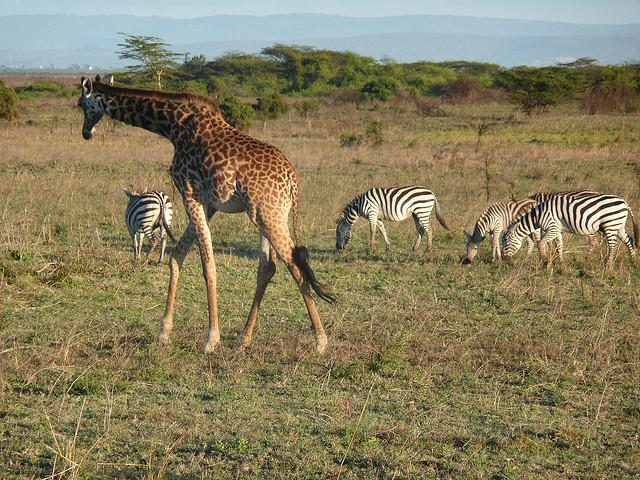What region is this most likely?

Choices:
A) new jersey
B) siberia
C) russia
D) east africa east africa 